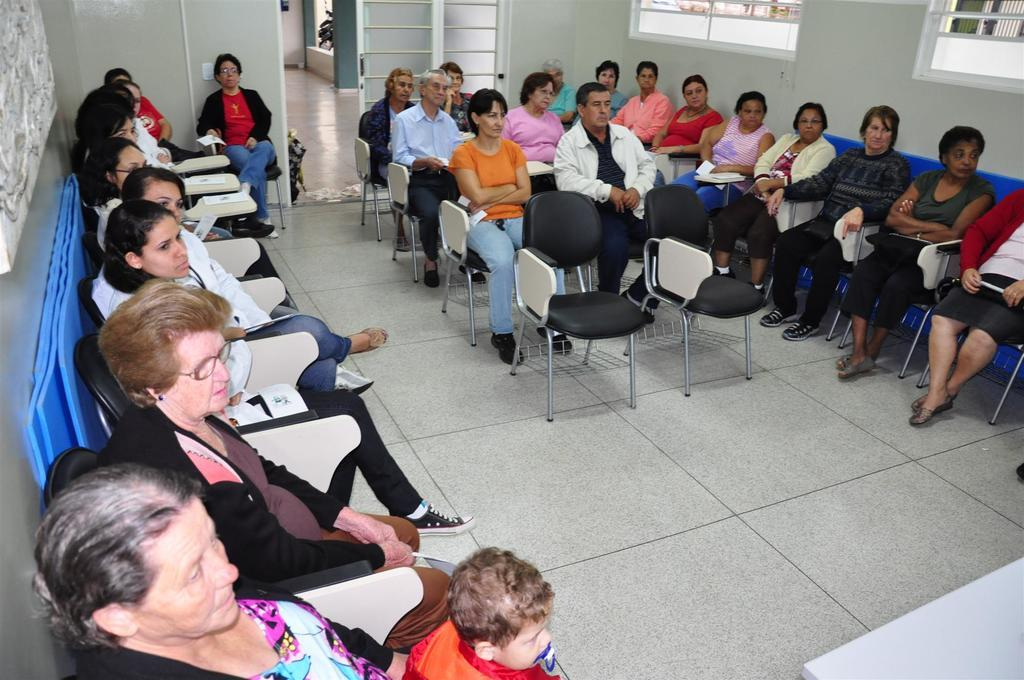What are the people in the image doing? The people in the image are sitting on chairs. What can be seen on the wall in the background of the image? There are windows on the wall in the background of the image. What is the surface beneath the people's feet in the image? There is a floor visible in the image. What type of oven can be seen in the image? There is no oven present in the image. How many rabbits are visible in the image? There are no rabbits present in the image. 